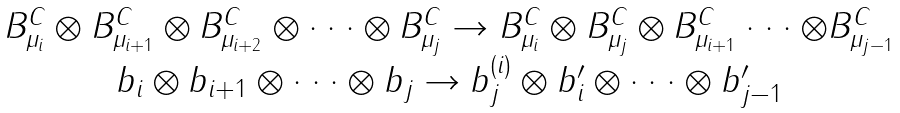<formula> <loc_0><loc_0><loc_500><loc_500>\begin{array} { c } B _ { \mu _ { i } } ^ { C } \otimes B _ { \mu _ { i + 1 } } ^ { C } \otimes B _ { \mu _ { i + 2 } } ^ { C } \otimes \cdot \cdot \cdot \otimes B _ { \mu _ { j } } ^ { C } \rightarrow B _ { \mu _ { i } } ^ { C } \otimes B _ { \mu _ { j } } ^ { C } \otimes B _ { \mu _ { i + 1 } } ^ { C } \cdot \cdot \cdot \otimes B _ { \mu _ { j - 1 } } ^ { C } \\ b _ { i } \otimes b _ { i + 1 } \otimes \cdot \cdot \cdot \otimes b _ { j } \rightarrow b _ { j } ^ { ( i ) } \otimes b _ { i } ^ { \prime } \otimes \cdot \cdot \cdot \otimes b _ { j - 1 } ^ { \prime } \end{array}</formula> 